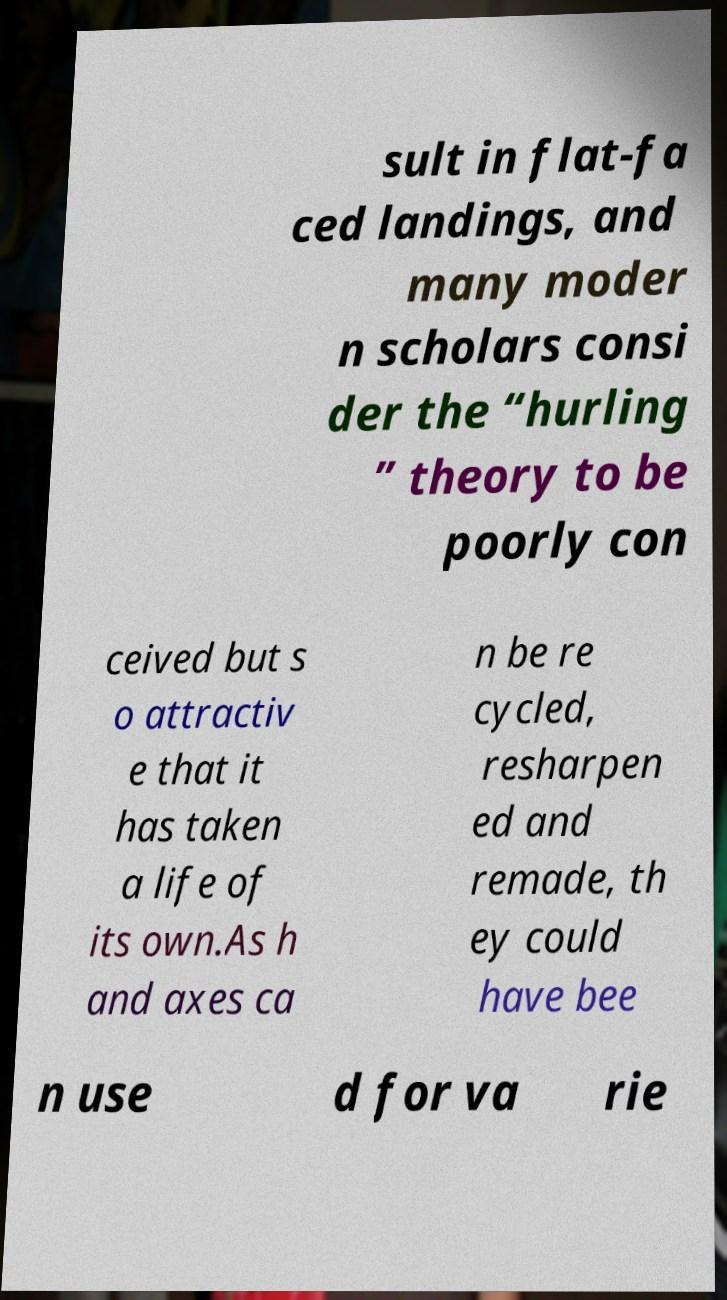Please identify and transcribe the text found in this image. sult in flat-fa ced landings, and many moder n scholars consi der the “hurling ” theory to be poorly con ceived but s o attractiv e that it has taken a life of its own.As h and axes ca n be re cycled, resharpen ed and remade, th ey could have bee n use d for va rie 